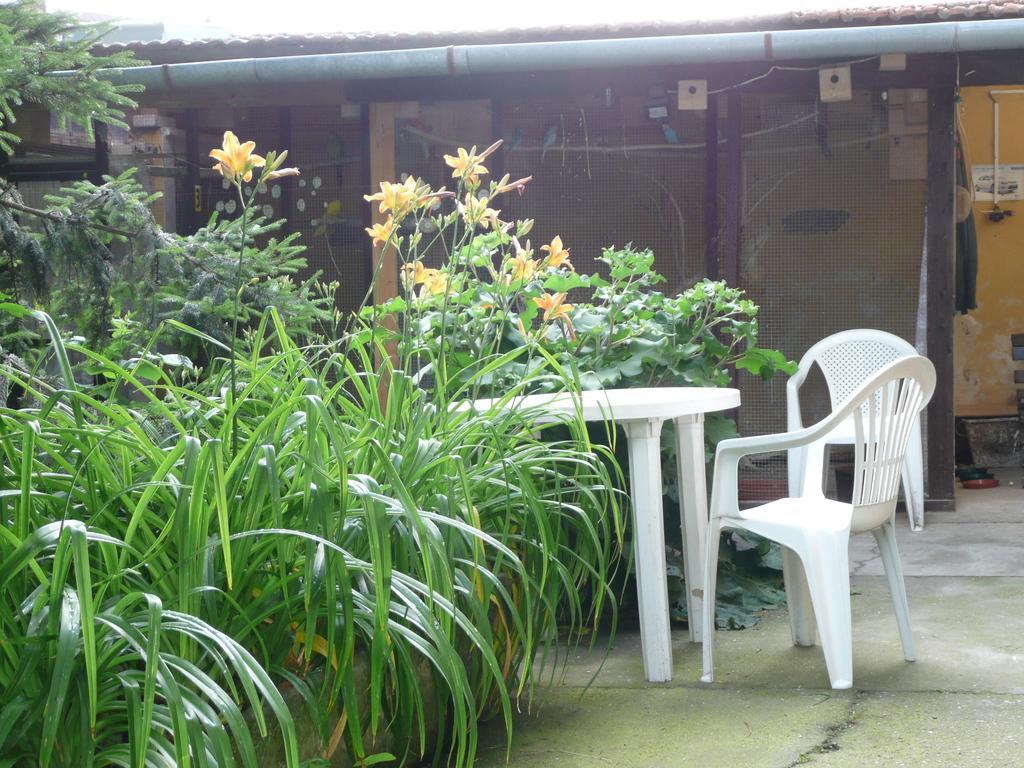How would you summarize this image in a sentence or two? this picture shows few plants and a house and we see a table and two chairs. 